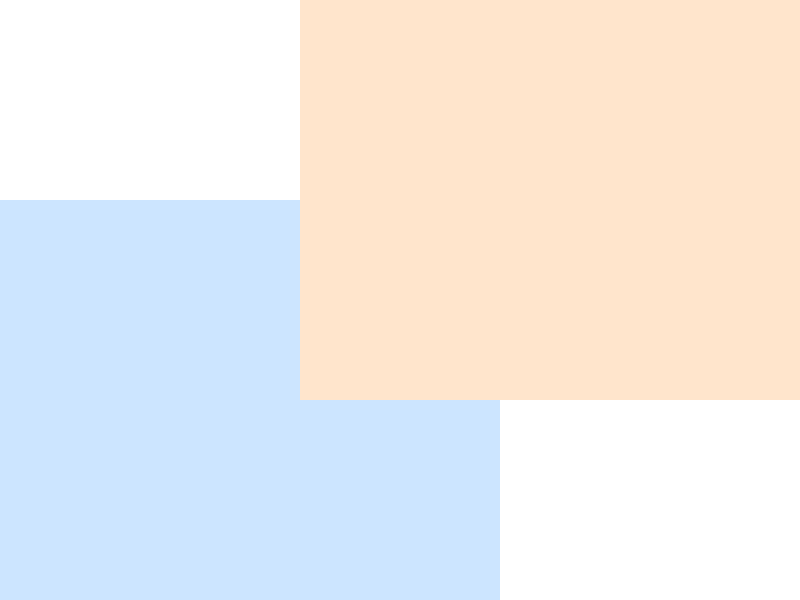In the diagram, two rectangles represent different brain regions affected by injuries: the blue rectangle (ABCD) represents the motor cortex, and the orange rectangle (EFGH) represents the cerebellum. Given that the coordinates of the vertices are as shown, calculate the area of the overlapping region (in square units) where both the motor cortex and cerebellum are affected. To find the area of the overlapping region, we need to:

1. Identify the overlapping rectangle:
   - Left edge: x = 3 (from rectangle EFGH)
   - Right edge: x = 5 (from rectangle ABCD)
   - Bottom edge: y = 2 (from rectangle EFGH)
   - Top edge: y = 4 (from rectangle ABCD)

2. Calculate the width of the overlapping rectangle:
   $w = 5 - 3 = 2$

3. Calculate the height of the overlapping rectangle:
   $h = 4 - 2 = 2$

4. Calculate the area of the overlapping rectangle:
   $A = w \times h = 2 \times 2 = 4$

Therefore, the area of the overlapping region is 4 square units.
Answer: 4 square units 